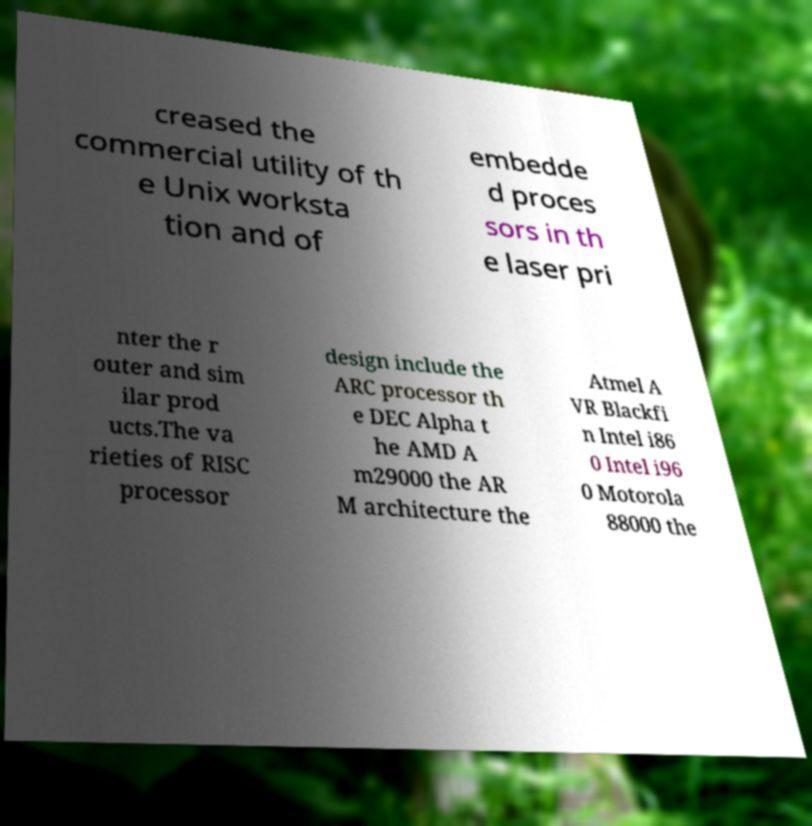There's text embedded in this image that I need extracted. Can you transcribe it verbatim? creased the commercial utility of th e Unix worksta tion and of embedde d proces sors in th e laser pri nter the r outer and sim ilar prod ucts.The va rieties of RISC processor design include the ARC processor th e DEC Alpha t he AMD A m29000 the AR M architecture the Atmel A VR Blackfi n Intel i86 0 Intel i96 0 Motorola 88000 the 